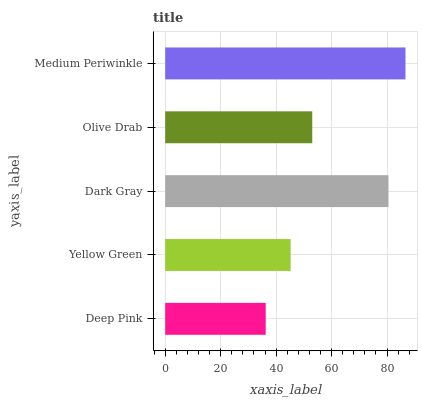Is Deep Pink the minimum?
Answer yes or no. Yes. Is Medium Periwinkle the maximum?
Answer yes or no. Yes. Is Yellow Green the minimum?
Answer yes or no. No. Is Yellow Green the maximum?
Answer yes or no. No. Is Yellow Green greater than Deep Pink?
Answer yes or no. Yes. Is Deep Pink less than Yellow Green?
Answer yes or no. Yes. Is Deep Pink greater than Yellow Green?
Answer yes or no. No. Is Yellow Green less than Deep Pink?
Answer yes or no. No. Is Olive Drab the high median?
Answer yes or no. Yes. Is Olive Drab the low median?
Answer yes or no. Yes. Is Deep Pink the high median?
Answer yes or no. No. Is Deep Pink the low median?
Answer yes or no. No. 